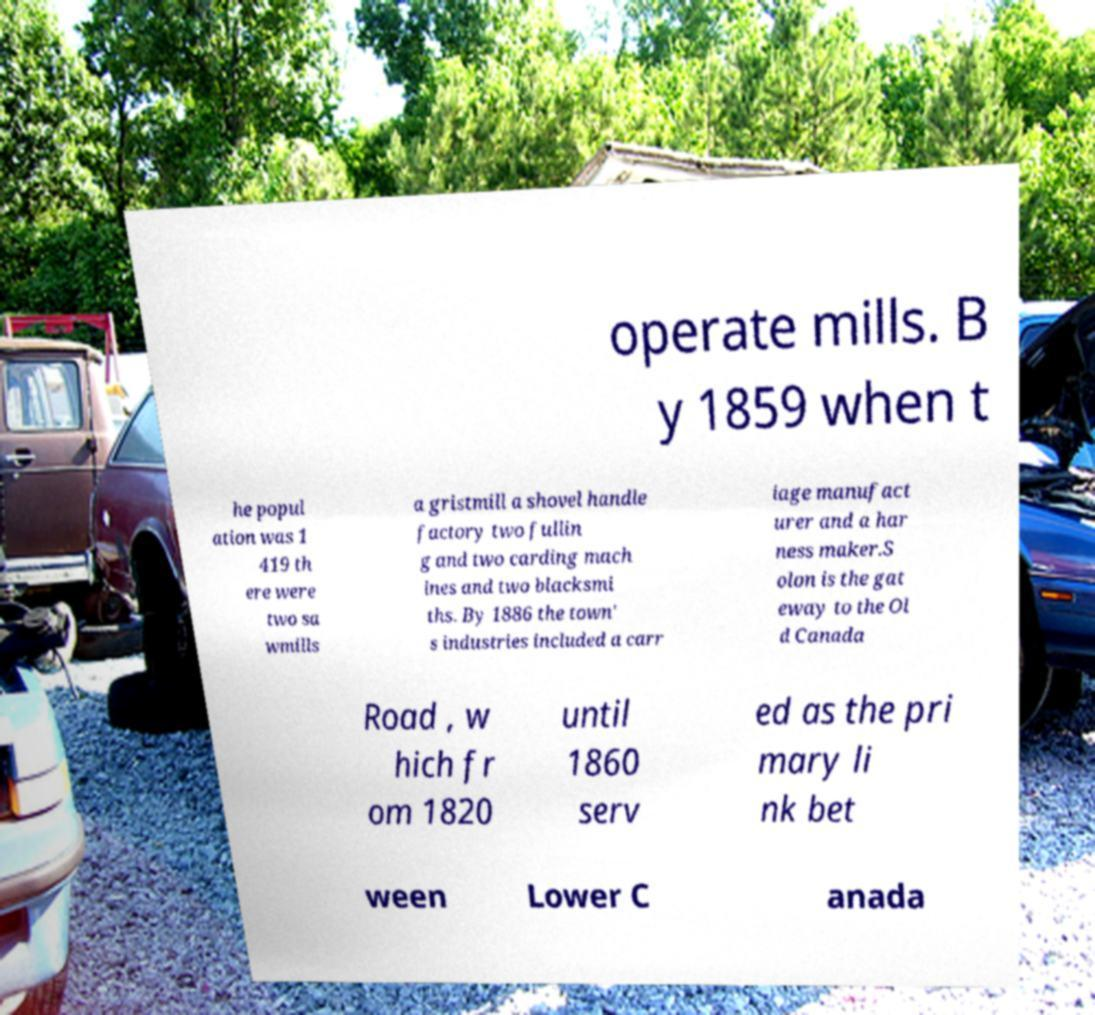Could you assist in decoding the text presented in this image and type it out clearly? operate mills. B y 1859 when t he popul ation was 1 419 th ere were two sa wmills a gristmill a shovel handle factory two fullin g and two carding mach ines and two blacksmi ths. By 1886 the town' s industries included a carr iage manufact urer and a har ness maker.S olon is the gat eway to the Ol d Canada Road , w hich fr om 1820 until 1860 serv ed as the pri mary li nk bet ween Lower C anada 